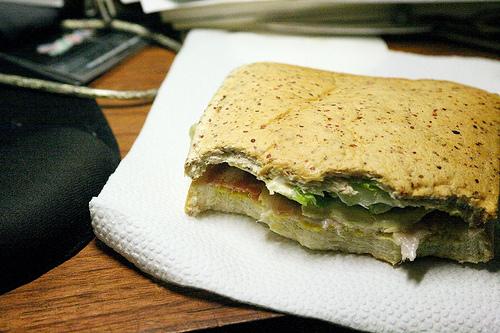What are they using instead of a plate?
Be succinct. Napkin. Is the sandwich half eaten?
Keep it brief. Yes. Is there lettuce on the sandwich?
Keep it brief. Yes. 